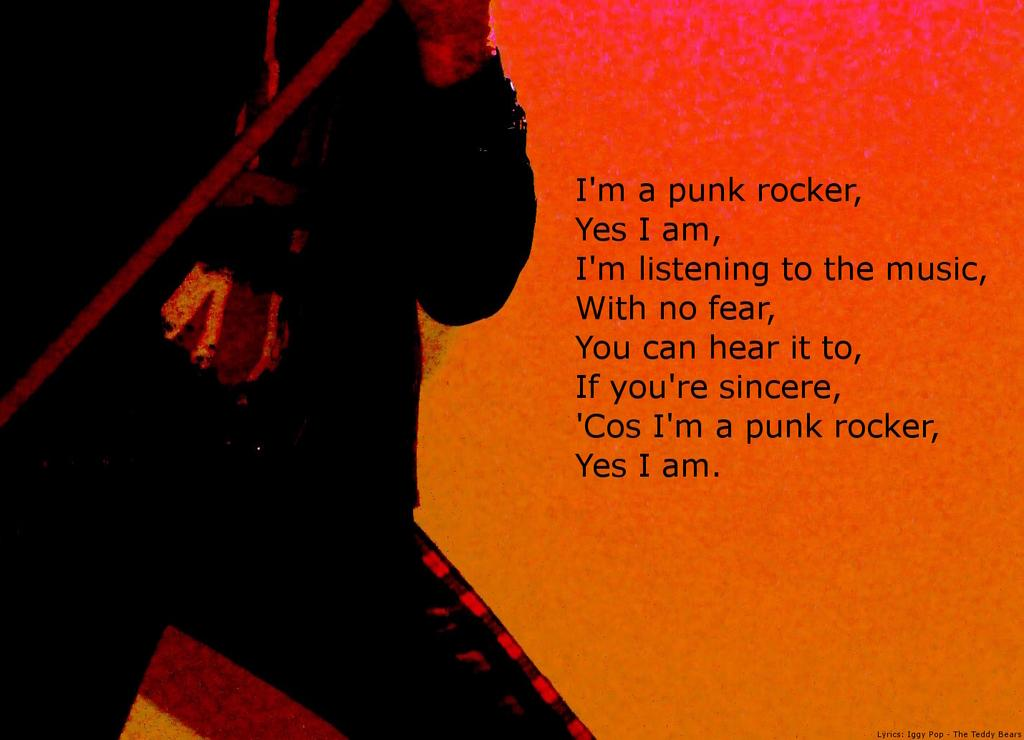What is the main subject of the image? There is a depiction of a person in the image. What else can be seen in the image besides the person? There is some text in the image. What type of machine is visible in the image? There is no machine present in the image. Can you see any cables in the image? There is no mention of cables in the provided facts, so it cannot be determined if any are present in the image. Is there a beetle crawling on the person in the image? There is no mention of a beetle in the provided facts, so it cannot be determined if one is present in the image. 